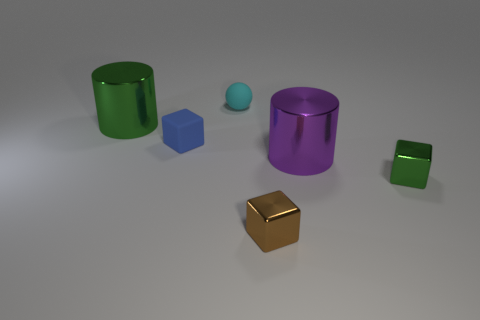What colors are the objects in the image? There are objects in green, cyan, blue, purple, and gold colors. 